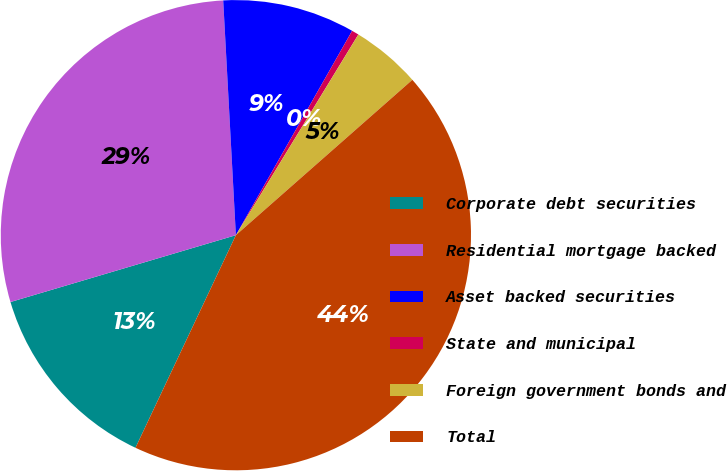Convert chart to OTSL. <chart><loc_0><loc_0><loc_500><loc_500><pie_chart><fcel>Corporate debt securities<fcel>Residential mortgage backed<fcel>Asset backed securities<fcel>State and municipal<fcel>Foreign government bonds and<fcel>Total<nl><fcel>13.39%<fcel>28.73%<fcel>9.09%<fcel>0.49%<fcel>4.79%<fcel>43.51%<nl></chart> 